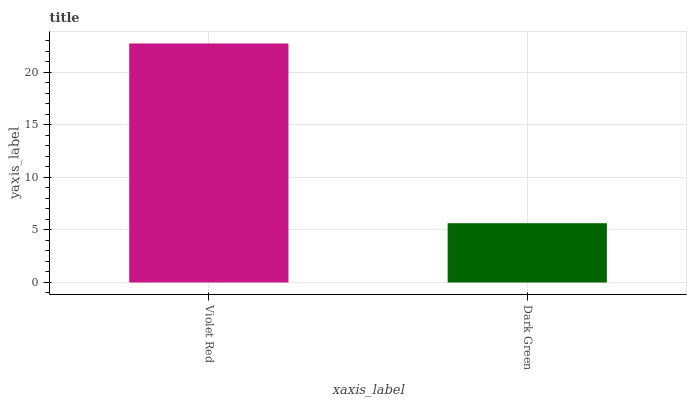Is Dark Green the minimum?
Answer yes or no. Yes. Is Violet Red the maximum?
Answer yes or no. Yes. Is Dark Green the maximum?
Answer yes or no. No. Is Violet Red greater than Dark Green?
Answer yes or no. Yes. Is Dark Green less than Violet Red?
Answer yes or no. Yes. Is Dark Green greater than Violet Red?
Answer yes or no. No. Is Violet Red less than Dark Green?
Answer yes or no. No. Is Violet Red the high median?
Answer yes or no. Yes. Is Dark Green the low median?
Answer yes or no. Yes. Is Dark Green the high median?
Answer yes or no. No. Is Violet Red the low median?
Answer yes or no. No. 